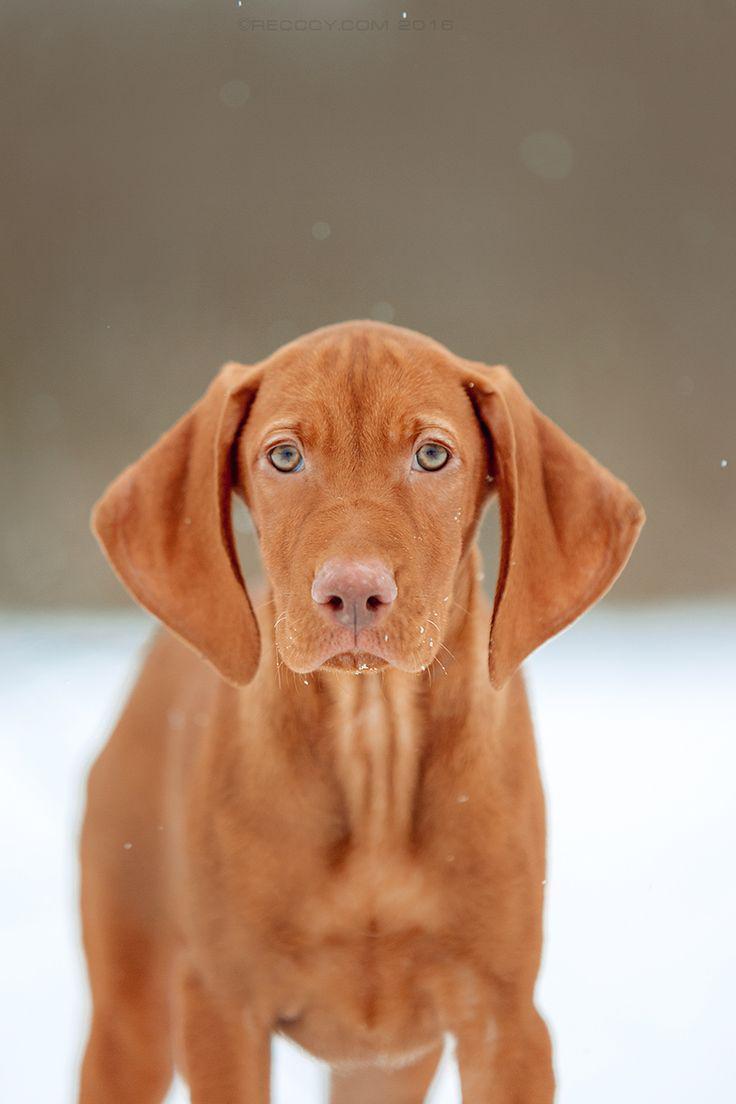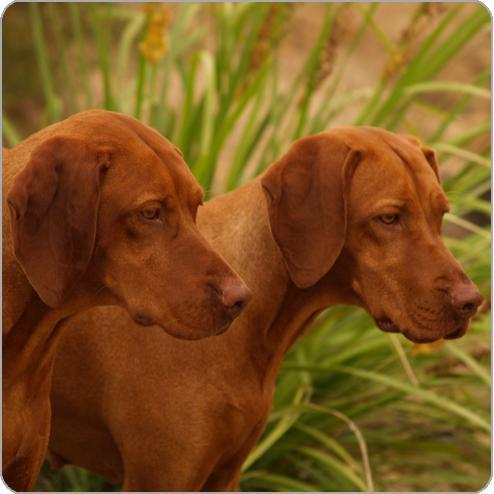The first image is the image on the left, the second image is the image on the right. Considering the images on both sides, is "A dog is wearing a red collar in the right image." valid? Answer yes or no. No. The first image is the image on the left, the second image is the image on the right. Given the left and right images, does the statement "In at least one image there is a light brown puppy with a red and black collar sitting forward." hold true? Answer yes or no. No. 